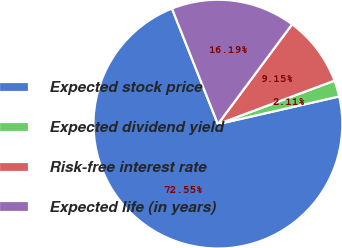Convert chart to OTSL. <chart><loc_0><loc_0><loc_500><loc_500><pie_chart><fcel>Expected stock price<fcel>Expected dividend yield<fcel>Risk-free interest rate<fcel>Expected life (in years)<nl><fcel>72.55%<fcel>2.11%<fcel>9.15%<fcel>16.19%<nl></chart> 